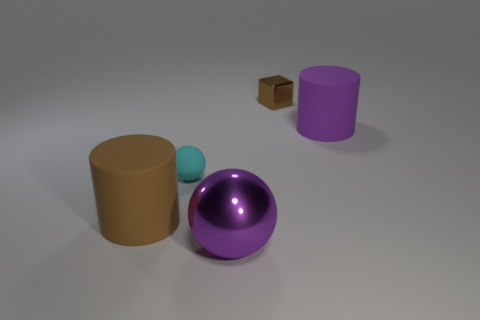There is a purple object that is behind the cyan rubber thing; does it have the same shape as the large brown object?
Your answer should be compact. Yes. There is a object that is made of the same material as the brown cube; what color is it?
Provide a succinct answer. Purple. There is a purple thing in front of the big brown thing; what is its material?
Offer a very short reply. Metal. Is the shape of the tiny cyan object the same as the brown thing that is behind the big purple rubber thing?
Give a very brief answer. No. There is a large thing that is behind the purple sphere and in front of the cyan sphere; what is it made of?
Give a very brief answer. Rubber. There is a sphere that is the same size as the brown matte cylinder; what color is it?
Your answer should be compact. Purple. Are the tiny cyan sphere and the large object that is to the right of the tiny brown cube made of the same material?
Make the answer very short. Yes. How many other objects are the same size as the brown metallic thing?
Give a very brief answer. 1. There is a rubber ball left of the metallic object behind the large purple shiny sphere; are there any big rubber cylinders in front of it?
Your answer should be compact. Yes. What size is the brown cylinder?
Your answer should be very brief. Large. 